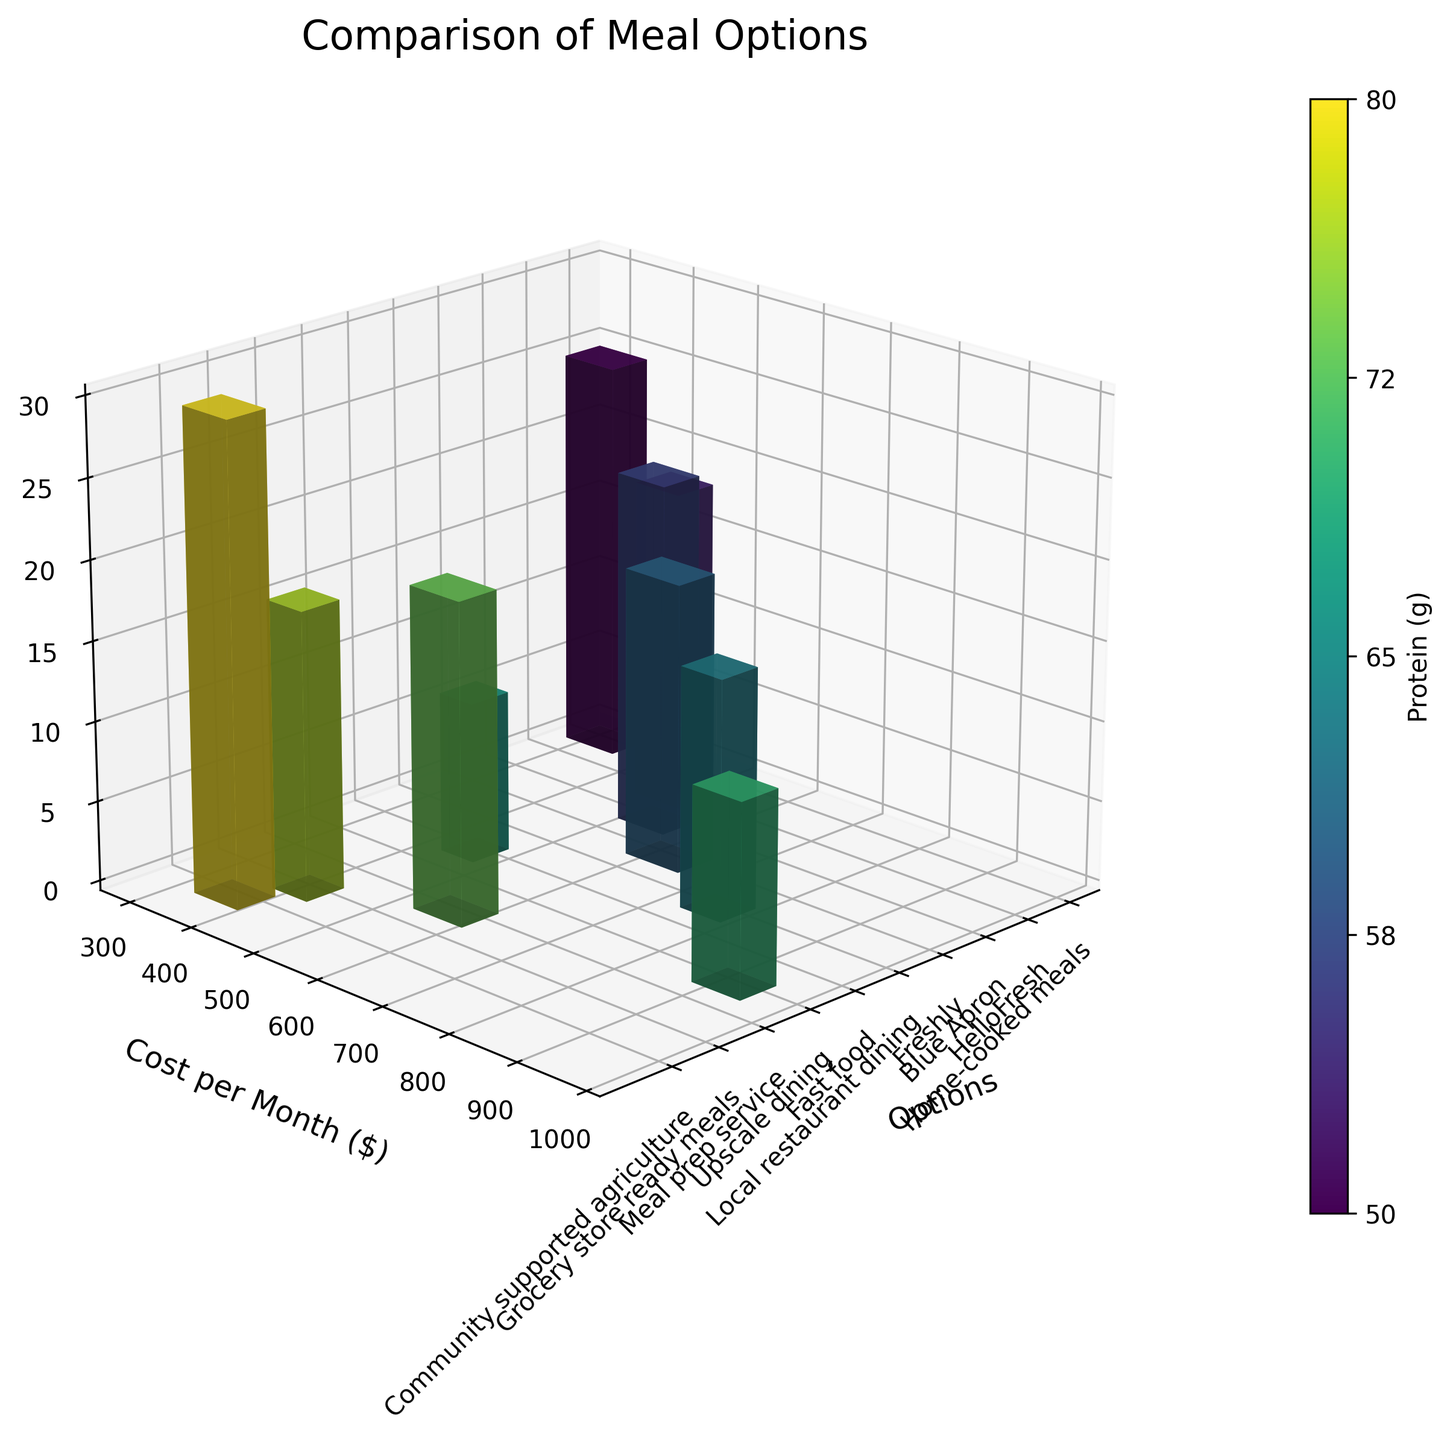What's the title of the figure? The title of the figure is typically displayed at the top of the plot. By reading what's there, we can see that it says "Comparison of Meal Options".
Answer: Comparison of Meal Options What are the axes representing? In 3D bar plots, the axes labels provide this information. The x-axis represents different options, the y-axis represents the cost per month in dollars, and the z-axis represents fiber in grams.
Answer: Options, Cost per Month ($), Fiber (g) Which meal option has the highest monthly cost? By observing the y-axis (Cost per Month) and looking for the tallest bar in the y-direction, we identify that "Upscale dining" has the highest cost at $900.
Answer: Upscale dining How much protein is provided by Blue Apron? The color bar legend indicates protein content. By identifying the bar color corresponding to Blue Apron and referring to the color legend, we see that Blue Apron provides 70 grams of protein.
Answer: 70 grams Which meal option offers the highest fiber content? We should look at the height along the z-axis for the tallest bar, which represents fiber content. The bar for "Community supported agriculture" is the highest, indicating it offers the most fiber at 30 grams.
Answer: Community supported agriculture How does the monthly cost of meal delivery services (combined) compare to dining out options (combined)? Add up the monthly costs for meal delivery services (HelloFresh: $480, Blue Apron: $520, Freshly: $600, Meal prep service: $550, Grocery store ready meals: $400) and compare the sum to the combined costs for dining out (Local restaurant dining: $750, Fast food: $450, Upscale dining: $900).
Answer: Meal delivery services: $2550 vs. Dining out: $2100 Which options cost less than $500 per month but offer at least 70 grams of protein? Identify the bars on the plot where the cost (y-axis) is less than $500 and the associated protein content (color) is 70 grams or more. "Community supported agriculture" meets these criteria at $350 with 70 grams of protein.
Answer: Community supported agriculture What is the range of fiber content available across all options? To find the range, identify the lowest and highest fiber values indicated by the z-axis on the plot. The lowest is 10 grams (Fast food) and the highest is 30 grams (Community supported agriculture). The range is thus 30 - 10.
Answer: 20 grams How does the cost of home-cooked meals compare to grocery store ready meals? By comparing the positions of the respective bars along the y-axis, we see home-cooked meals cost $300 while grocery store ready meals cost $400.
Answer: Home-cooked meals are $100 cheaper than grocery store ready meals Among meal delivery services, which provides the highest amount of fiber? Compare the fiber heights (z-axis) among HelloFresh, Blue Apron, Freshly, and Meal prep service. Blue Apron has a fiber content of 22 grams, which is the highest among these options.
Answer: Blue Apron 